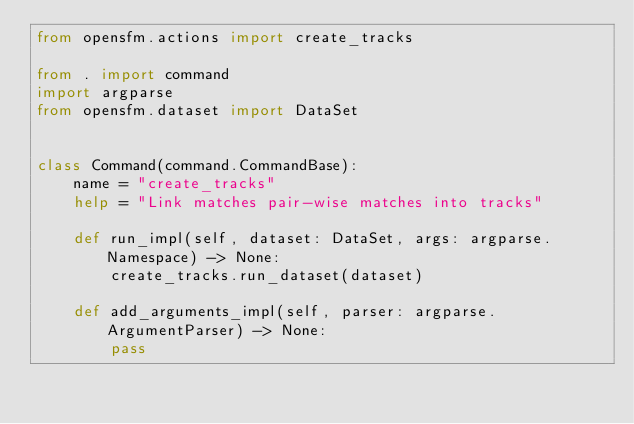<code> <loc_0><loc_0><loc_500><loc_500><_Python_>from opensfm.actions import create_tracks

from . import command
import argparse
from opensfm.dataset import DataSet


class Command(command.CommandBase):
    name = "create_tracks"
    help = "Link matches pair-wise matches into tracks"

    def run_impl(self, dataset: DataSet, args: argparse.Namespace) -> None:
        create_tracks.run_dataset(dataset)

    def add_arguments_impl(self, parser: argparse.ArgumentParser) -> None:
        pass
</code> 